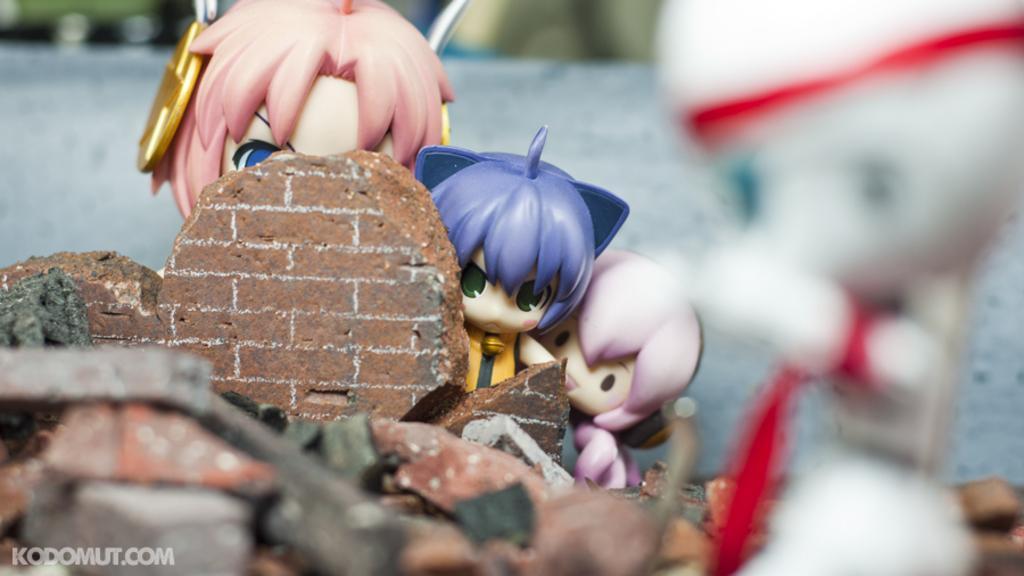How would you summarize this image in a sentence or two? In this image I can see few toys. At the bottom left hand corner I can see some text. 